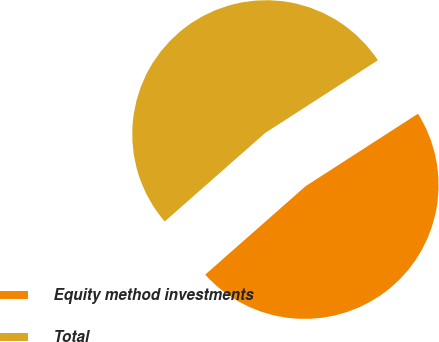<chart> <loc_0><loc_0><loc_500><loc_500><pie_chart><fcel>Equity method investments<fcel>Total<nl><fcel>47.62%<fcel>52.38%<nl></chart> 